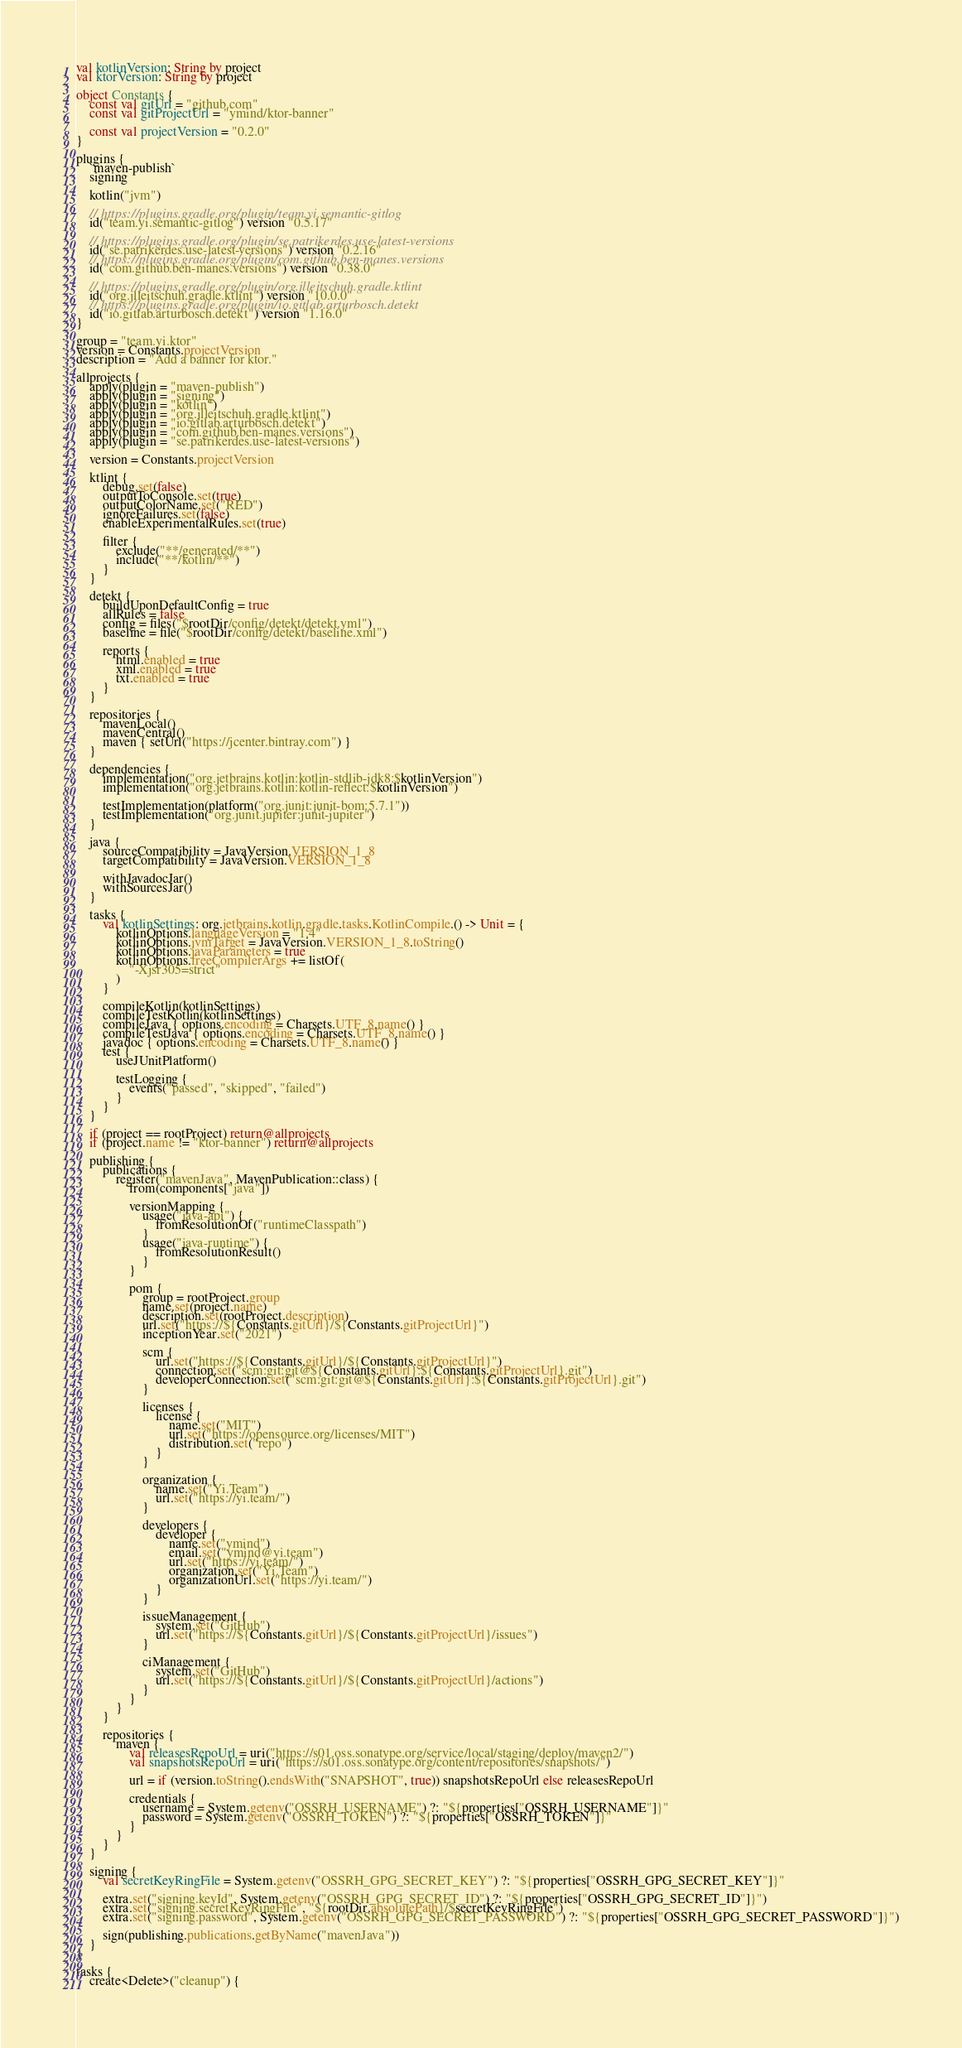<code> <loc_0><loc_0><loc_500><loc_500><_Kotlin_>val kotlinVersion: String by project
val ktorVersion: String by project

object Constants {
    const val gitUrl = "github.com"
    const val gitProjectUrl = "ymind/ktor-banner"

    const val projectVersion = "0.2.0"
}

plugins {
    `maven-publish`
    signing

    kotlin("jvm")

    // https://plugins.gradle.org/plugin/team.yi.semantic-gitlog
    id("team.yi.semantic-gitlog") version "0.5.17"

    // https://plugins.gradle.org/plugin/se.patrikerdes.use-latest-versions
    id("se.patrikerdes.use-latest-versions") version "0.2.16"
    // https://plugins.gradle.org/plugin/com.github.ben-manes.versions
    id("com.github.ben-manes.versions") version "0.38.0"

    // https://plugins.gradle.org/plugin/org.jlleitschuh.gradle.ktlint
    id("org.jlleitschuh.gradle.ktlint") version "10.0.0"
    // https://plugins.gradle.org/plugin/io.gitlab.arturbosch.detekt
    id("io.gitlab.arturbosch.detekt") version "1.16.0"
}

group = "team.yi.ktor"
version = Constants.projectVersion
description = "Add a banner for ktor."

allprojects {
    apply(plugin = "maven-publish")
    apply(plugin = "signing")
    apply(plugin = "kotlin")
    apply(plugin = "org.jlleitschuh.gradle.ktlint")
    apply(plugin = "io.gitlab.arturbosch.detekt")
    apply(plugin = "com.github.ben-manes.versions")
    apply(plugin = "se.patrikerdes.use-latest-versions")

    version = Constants.projectVersion

    ktlint {
        debug.set(false)
        outputToConsole.set(true)
        outputColorName.set("RED")
        ignoreFailures.set(false)
        enableExperimentalRules.set(true)

        filter {
            exclude("**/generated/**")
            include("**/kotlin/**")
        }
    }

    detekt {
        buildUponDefaultConfig = true
        allRules = false
        config = files("$rootDir/config/detekt/detekt.yml")
        baseline = file("$rootDir/config/detekt/baseline.xml")

        reports {
            html.enabled = true
            xml.enabled = true
            txt.enabled = true
        }
    }

    repositories {
        mavenLocal()
        mavenCentral()
        maven { setUrl("https://jcenter.bintray.com") }
    }

    dependencies {
        implementation("org.jetbrains.kotlin:kotlin-stdlib-jdk8:$kotlinVersion")
        implementation("org.jetbrains.kotlin:kotlin-reflect:$kotlinVersion")

        testImplementation(platform("org.junit:junit-bom:5.7.1"))
        testImplementation("org.junit.jupiter:junit-jupiter")
    }

    java {
        sourceCompatibility = JavaVersion.VERSION_1_8
        targetCompatibility = JavaVersion.VERSION_1_8

        withJavadocJar()
        withSourcesJar()
    }

    tasks {
        val kotlinSettings: org.jetbrains.kotlin.gradle.tasks.KotlinCompile.() -> Unit = {
            kotlinOptions.languageVersion = "1.4"
            kotlinOptions.jvmTarget = JavaVersion.VERSION_1_8.toString()
            kotlinOptions.javaParameters = true
            kotlinOptions.freeCompilerArgs += listOf(
                "-Xjsr305=strict"
            )
        }

        compileKotlin(kotlinSettings)
        compileTestKotlin(kotlinSettings)
        compileJava { options.encoding = Charsets.UTF_8.name() }
        compileTestJava { options.encoding = Charsets.UTF_8.name() }
        javadoc { options.encoding = Charsets.UTF_8.name() }
        test {
            useJUnitPlatform()

            testLogging {
                events("passed", "skipped", "failed")
            }
        }
    }

    if (project == rootProject) return@allprojects
    if (project.name != "ktor-banner") return@allprojects

    publishing {
        publications {
            register("mavenJava", MavenPublication::class) {
                from(components["java"])

                versionMapping {
                    usage("java-api") {
                        fromResolutionOf("runtimeClasspath")
                    }
                    usage("java-runtime") {
                        fromResolutionResult()
                    }
                }

                pom {
                    group = rootProject.group
                    name.set(project.name)
                    description.set(rootProject.description)
                    url.set("https://${Constants.gitUrl}/${Constants.gitProjectUrl}")
                    inceptionYear.set("2021")

                    scm {
                        url.set("https://${Constants.gitUrl}/${Constants.gitProjectUrl}")
                        connection.set("scm:git:git@${Constants.gitUrl}:${Constants.gitProjectUrl}.git")
                        developerConnection.set("scm:git:git@${Constants.gitUrl}:${Constants.gitProjectUrl}.git")
                    }

                    licenses {
                        license {
                            name.set("MIT")
                            url.set("https://opensource.org/licenses/MIT")
                            distribution.set("repo")
                        }
                    }

                    organization {
                        name.set("Yi.Team")
                        url.set("https://yi.team/")
                    }

                    developers {
                        developer {
                            name.set("ymind")
                            email.set("ymind@yi.team")
                            url.set("https://yi.team/")
                            organization.set("Yi.Team")
                            organizationUrl.set("https://yi.team/")
                        }
                    }

                    issueManagement {
                        system.set("GitHub")
                        url.set("https://${Constants.gitUrl}/${Constants.gitProjectUrl}/issues")
                    }

                    ciManagement {
                        system.set("GitHub")
                        url.set("https://${Constants.gitUrl}/${Constants.gitProjectUrl}/actions")
                    }
                }
            }
        }

        repositories {
            maven {
                val releasesRepoUrl = uri("https://s01.oss.sonatype.org/service/local/staging/deploy/maven2/")
                val snapshotsRepoUrl = uri("https://s01.oss.sonatype.org/content/repositories/snapshots/")

                url = if (version.toString().endsWith("SNAPSHOT", true)) snapshotsRepoUrl else releasesRepoUrl

                credentials {
                    username = System.getenv("OSSRH_USERNAME") ?: "${properties["OSSRH_USERNAME"]}"
                    password = System.getenv("OSSRH_TOKEN") ?: "${properties["OSSRH_TOKEN"]}"
                }
            }
        }
    }

    signing {
        val secretKeyRingFile = System.getenv("OSSRH_GPG_SECRET_KEY") ?: "${properties["OSSRH_GPG_SECRET_KEY"]}"

        extra.set("signing.keyId", System.getenv("OSSRH_GPG_SECRET_ID") ?: "${properties["OSSRH_GPG_SECRET_ID"]}")
        extra.set("signing.secretKeyRingFile", "${rootDir.absolutePath}/$secretKeyRingFile")
        extra.set("signing.password", System.getenv("OSSRH_GPG_SECRET_PASSWORD") ?: "${properties["OSSRH_GPG_SECRET_PASSWORD"]}")

        sign(publishing.publications.getByName("mavenJava"))
    }
}

tasks {
    create<Delete>("cleanup") {</code> 